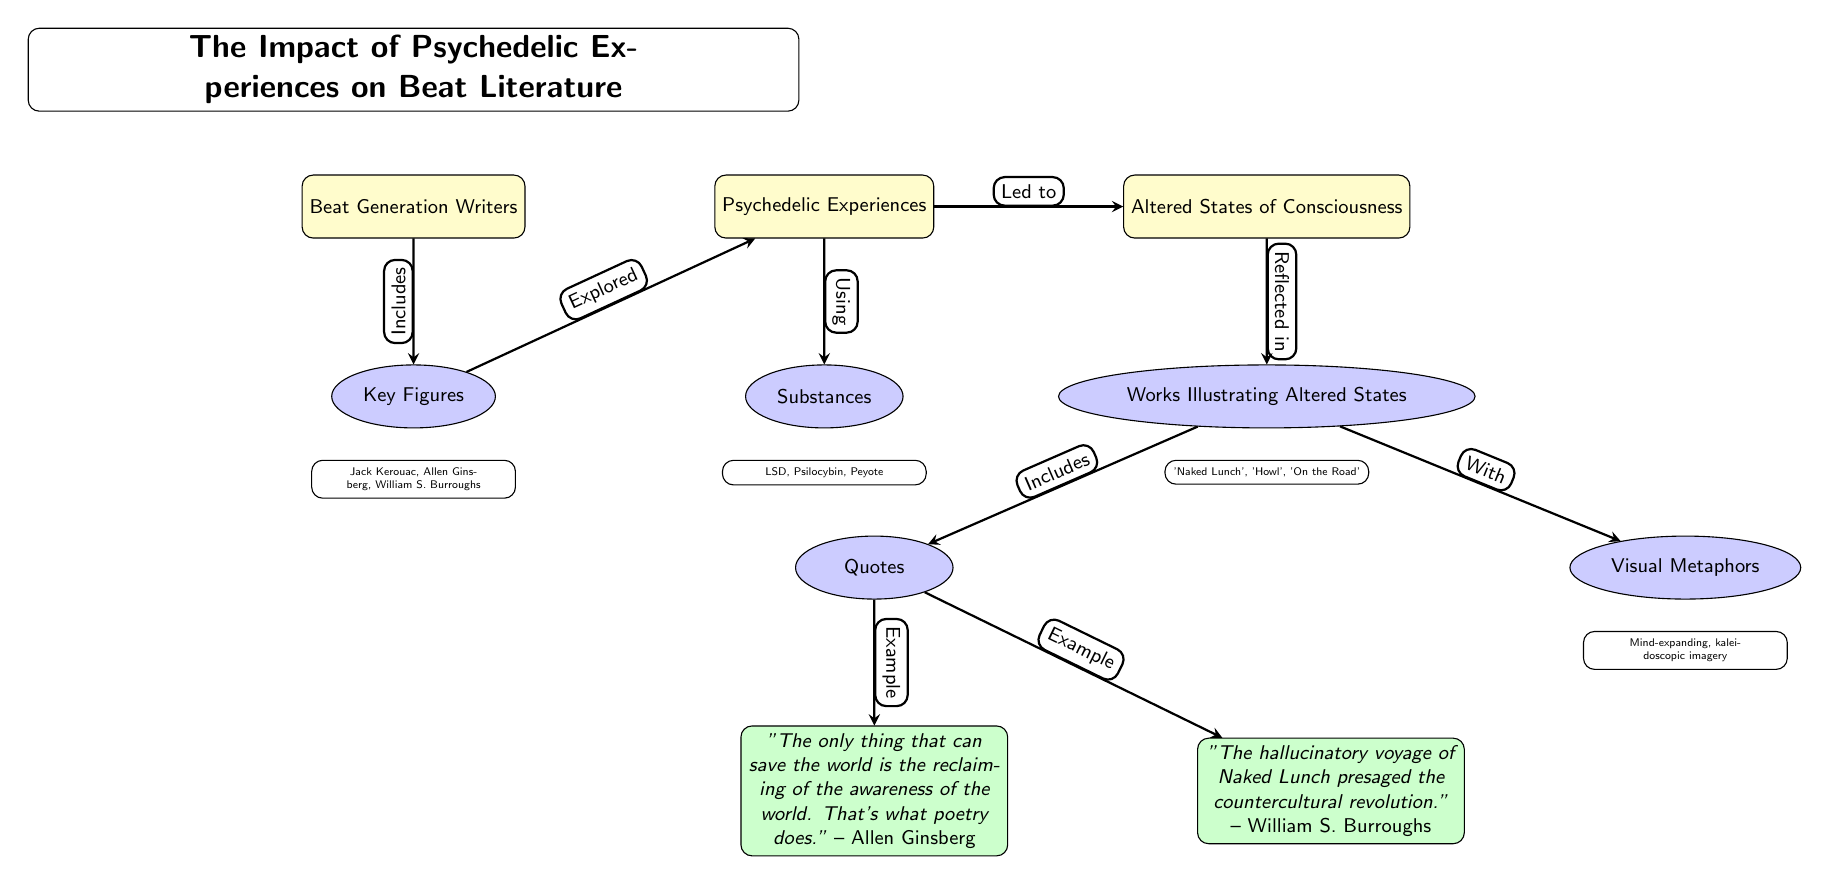What are the key figures in the Beat Generation? The diagram lists the key figures in the Beat Generation directly below the "Key Figures" node, which include Jack Kerouac, Allen Ginsberg, and William S. Burroughs.
Answer: Jack Kerouac, Allen Ginsberg, William S. Burroughs Which substances are associated with psychedelic experiences? Under the "Substances" node, the diagram specifies LSD, Psilocybin, and Peyote as the substances linked to psychedelic experiences.
Answer: LSD, Psilocybin, Peyote What type of imagery is often reflected in the works illustrating altered states? The "Visual Metaphors" node highlights that the imagery in these works is characterized by "Mind-expanding, kaleidoscopic imagery".
Answer: Mind-expanding, kaleidoscopic imagery How many quotes are provided in the diagram? The diagram includes two specific quotes under the "Quotes" node, which are examples provided for the impact of psychedelics in Beat literature.
Answer: 2 What is the relationship between "Psychedelic Experiences" and "Altered States of Consciousness"? The edge connecting "Psychedelic Experiences" and "Altered States of Consciousness" indicates a direct causal link, represented by the label "Led to".
Answer: Led to Which work is mentioned as presaging the countercultural revolution? The quote by William S. Burroughs mentions "Naked Lunch" as the work that presaged the countercultural revolution.
Answer: Naked Lunch What does the quote by Allen Ginsberg emphasize about poetry? The quote emphasizes that the purpose of poetry is to reclaim awareness of the world, as stated in his specific wording.
Answer: Reclaiming of the awareness of the world What does the "Works Illustrating Altered States" node include? Looking at the "Works Illustrating Altered States" node, the diagram shows that it includes 'Naked Lunch', 'Howl', and 'On the Road' as represented works.
Answer: 'Naked Lunch', 'Howl', 'On the Road' What is the primary theme connecting the Beat Generation writers? The central theme of the diagram connects the Beat Generation writers with psychedelic experiences, showing how these experiences influenced their literature.
Answer: Psychedelic Experiences 